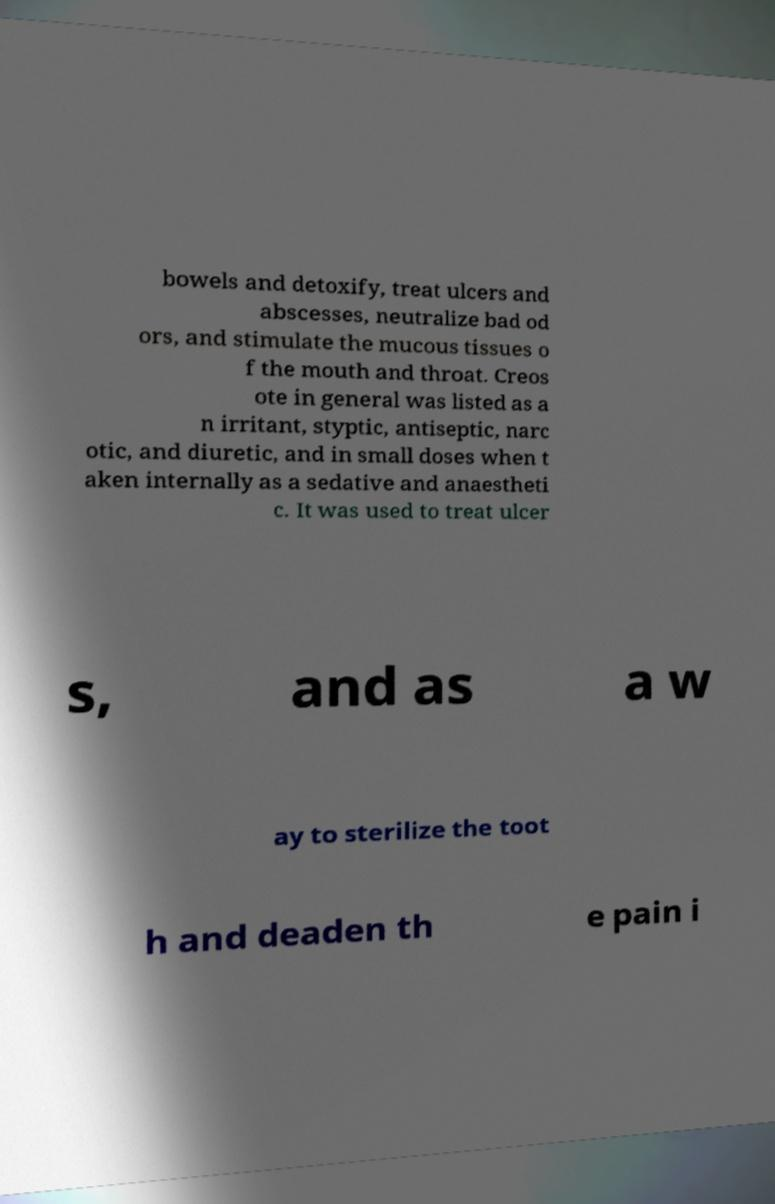There's text embedded in this image that I need extracted. Can you transcribe it verbatim? bowels and detoxify, treat ulcers and abscesses, neutralize bad od ors, and stimulate the mucous tissues o f the mouth and throat. Creos ote in general was listed as a n irritant, styptic, antiseptic, narc otic, and diuretic, and in small doses when t aken internally as a sedative and anaestheti c. It was used to treat ulcer s, and as a w ay to sterilize the toot h and deaden th e pain i 